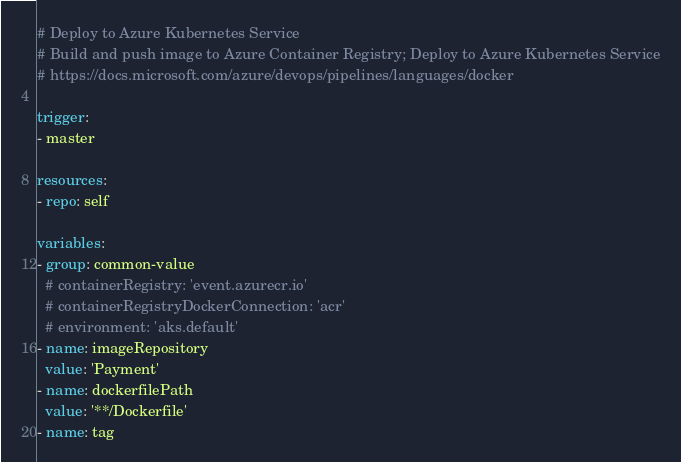<code> <loc_0><loc_0><loc_500><loc_500><_YAML_># Deploy to Azure Kubernetes Service
# Build and push image to Azure Container Registry; Deploy to Azure Kubernetes Service
# https://docs.microsoft.com/azure/devops/pipelines/languages/docker

trigger:
- master

resources:
- repo: self

variables:
- group: common-value
  # containerRegistry: 'event.azurecr.io'
  # containerRegistryDockerConnection: 'acr'
  # environment: 'aks.default'
- name: imageRepository
  value: 'Payment'
- name: dockerfilePath
  value: '**/Dockerfile'
- name: tag</code> 